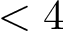Convert formula to latex. <formula><loc_0><loc_0><loc_500><loc_500>< 4</formula> 